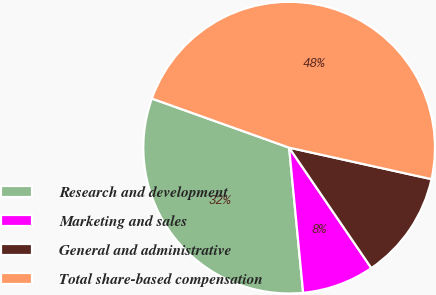Convert chart to OTSL. <chart><loc_0><loc_0><loc_500><loc_500><pie_chart><fcel>Research and development<fcel>Marketing and sales<fcel>General and administrative<fcel>Total share-based compensation<nl><fcel>32.0%<fcel>8.0%<fcel>12.0%<fcel>48.0%<nl></chart> 